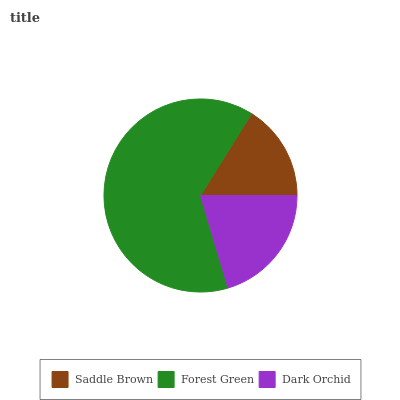Is Saddle Brown the minimum?
Answer yes or no. Yes. Is Forest Green the maximum?
Answer yes or no. Yes. Is Dark Orchid the minimum?
Answer yes or no. No. Is Dark Orchid the maximum?
Answer yes or no. No. Is Forest Green greater than Dark Orchid?
Answer yes or no. Yes. Is Dark Orchid less than Forest Green?
Answer yes or no. Yes. Is Dark Orchid greater than Forest Green?
Answer yes or no. No. Is Forest Green less than Dark Orchid?
Answer yes or no. No. Is Dark Orchid the high median?
Answer yes or no. Yes. Is Dark Orchid the low median?
Answer yes or no. Yes. Is Saddle Brown the high median?
Answer yes or no. No. Is Forest Green the low median?
Answer yes or no. No. 